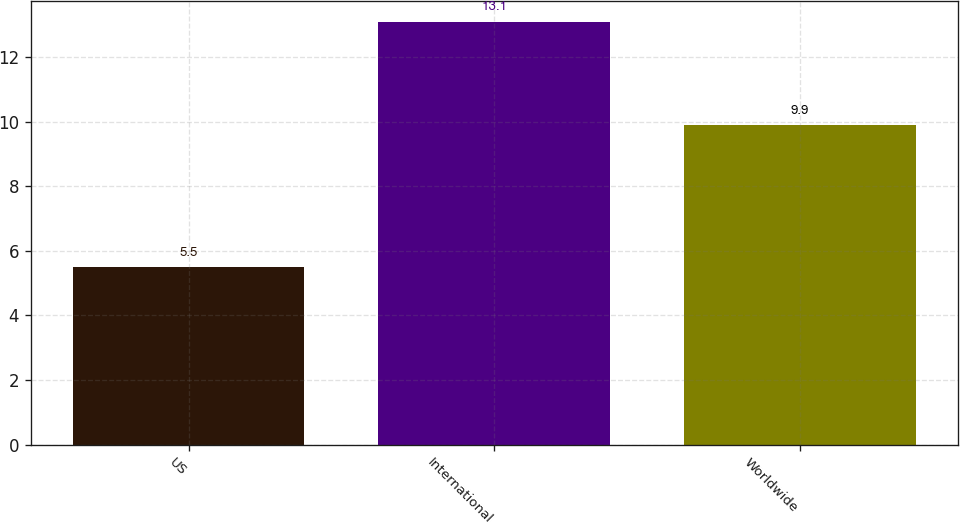Convert chart to OTSL. <chart><loc_0><loc_0><loc_500><loc_500><bar_chart><fcel>US<fcel>International<fcel>Worldwide<nl><fcel>5.5<fcel>13.1<fcel>9.9<nl></chart> 